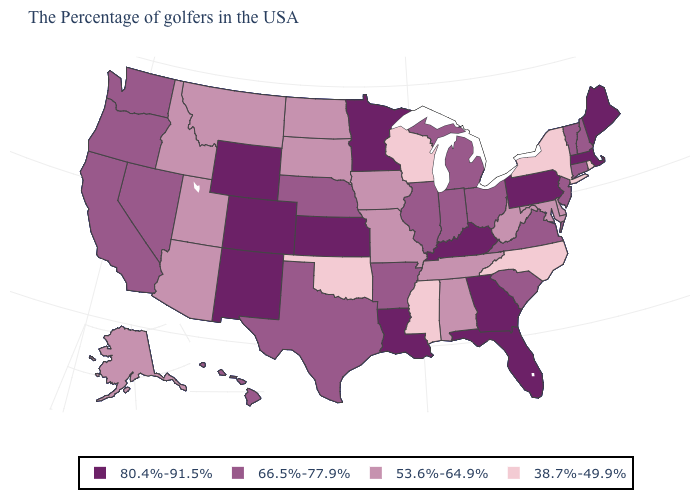What is the lowest value in the USA?
Write a very short answer. 38.7%-49.9%. How many symbols are there in the legend?
Keep it brief. 4. What is the value of Connecticut?
Give a very brief answer. 66.5%-77.9%. Name the states that have a value in the range 80.4%-91.5%?
Short answer required. Maine, Massachusetts, Pennsylvania, Florida, Georgia, Kentucky, Louisiana, Minnesota, Kansas, Wyoming, Colorado, New Mexico. How many symbols are there in the legend?
Quick response, please. 4. Which states hav the highest value in the West?
Be succinct. Wyoming, Colorado, New Mexico. Which states have the lowest value in the USA?
Answer briefly. Rhode Island, New York, North Carolina, Wisconsin, Mississippi, Oklahoma. Does Maine have a higher value than Wyoming?
Give a very brief answer. No. Among the states that border California , does Nevada have the highest value?
Give a very brief answer. Yes. What is the lowest value in states that border South Carolina?
Quick response, please. 38.7%-49.9%. Name the states that have a value in the range 38.7%-49.9%?
Keep it brief. Rhode Island, New York, North Carolina, Wisconsin, Mississippi, Oklahoma. Does Indiana have a lower value than Louisiana?
Give a very brief answer. Yes. Which states have the highest value in the USA?
Write a very short answer. Maine, Massachusetts, Pennsylvania, Florida, Georgia, Kentucky, Louisiana, Minnesota, Kansas, Wyoming, Colorado, New Mexico. How many symbols are there in the legend?
Answer briefly. 4. What is the lowest value in states that border Arizona?
Write a very short answer. 53.6%-64.9%. 